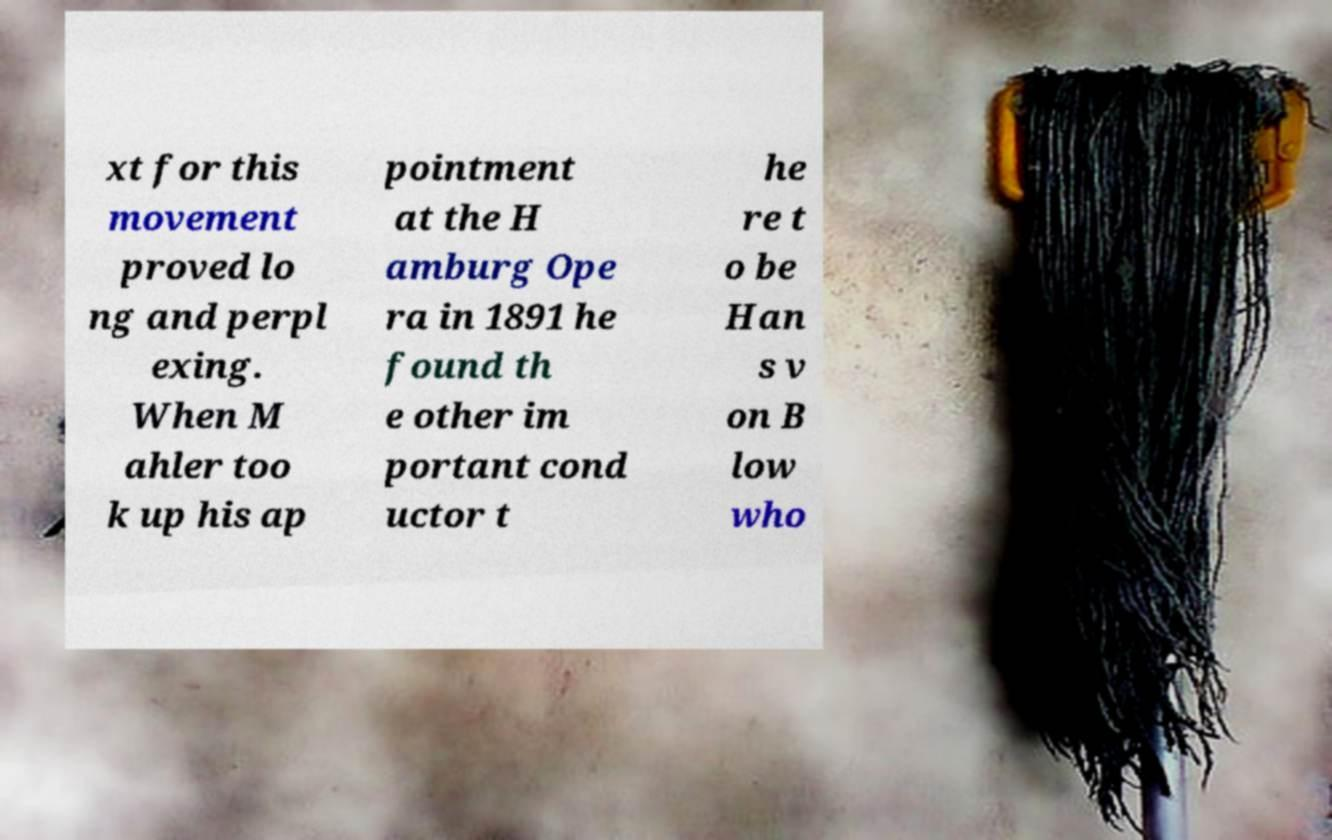There's text embedded in this image that I need extracted. Can you transcribe it verbatim? xt for this movement proved lo ng and perpl exing. When M ahler too k up his ap pointment at the H amburg Ope ra in 1891 he found th e other im portant cond uctor t he re t o be Han s v on B low who 